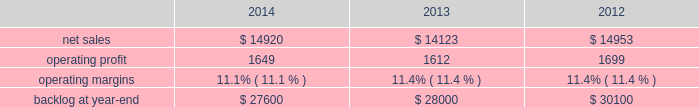2014 , 2013 and 2012 .
The decrease in our consolidated net adjustments for 2014 compared to 2013 was primarily due to a decrease in profit booking rate adjustments at our aeronautics , mfc and mst business segments .
The increase in our consolidated net adjustments for 2013 as compared to 2012 was primarily due to an increase in profit booking rate adjustments at our mst and mfc business segments and , to a lesser extent , the increase in the favorable resolution of contractual matters for the corporation .
The consolidated net adjustments for 2014 are inclusive of approximately $ 650 million in unfavorable items , which include reserves recorded on certain training and logistics solutions programs at mst and net warranty reserve adjustments for various programs ( including jassm and gmlrs ) at mfc as described in the respective business segment 2019s results of operations below .
The consolidated net adjustments for 2013 and 2012 are inclusive of approximately $ 600 million and $ 500 million in unfavorable items , which include a significant profit reduction on the f-35 development contract in both years , as well as a significant profit reduction on the c-5 program in 2013 , each as described in our aeronautics business segment 2019s results of operations discussion below .
Aeronautics our aeronautics business segment is engaged in the research , design , development , manufacture , integration , sustainment , support and upgrade of advanced military aircraft , including combat and air mobility aircraft , unmanned air vehicles and related technologies .
Aeronautics 2019 major programs include the f-35 lightning ii joint strike fighter , c-130 hercules , f-16 fighting falcon , f-22 raptor and the c-5m super galaxy .
Aeronautics 2019 operating results included the following ( in millions ) : .
2014 compared to 2013 aeronautics 2019 net sales for 2014 increased $ 797 million , or 6% ( 6 % ) , compared to 2013 .
The increase was primarily attributable to higher net sales of approximately $ 790 million for f-35 production contracts due to increased volume and sustainment activities ; about $ 55 million for the f-16 program due to increased deliveries ( 17 aircraft delivered in 2014 compared to 13 delivered in 2013 ) partially offset by contract mix ; and approximately $ 45 million for the f-22 program due to increased risk retirements .
The increases were partially offset by lower net sales of approximately $ 55 million for the f-35 development contract due to decreased volume , partially offset by the absence in 2014 of the downward revision to the profit booking rate that occurred in 2013 ; and about $ 40 million for the c-130 program due to fewer deliveries ( 24 aircraft delivered in 2014 compared to 25 delivered in 2013 ) and decreased sustainment activities , partially offset by contract mix .
Aeronautics 2019 operating profit for 2014 increased $ 37 million , or 2% ( 2 % ) , compared to 2013 .
The increase was primarily attributable to higher operating profit of approximately $ 85 million for the f-35 development contract due to the absence in 2014 of the downward revision to the profit booking rate that occurred in 2013 ; about $ 75 million for the f-22 program due to increased risk retirements ; approximately $ 50 million for the c-130 program due to increased risk retirements and contract mix , partially offset by fewer deliveries ; and about $ 25 million for the c-5 program due to the absence in 2014 of the downward revisions to the profit booking rate that occurred in 2013 .
The increases were partially offset by lower operating profit of approximately $ 130 million for the f-16 program due to decreased risk retirements , partially offset by increased deliveries ; and about $ 70 million for sustainment activities due to decreased risk retirements and volume .
Operating profit was comparable for f-35 production contracts as higher volume was offset by lower risk retirements .
Adjustments not related to volume , including net profit booking rate adjustments and other matters , were approximately $ 105 million lower for 2014 compared to 2013 .
2013 compared to 2012 aeronautics 2019 net sales for 2013 decreased $ 830 million , or 6% ( 6 % ) , compared to 2012 .
The decrease was primarily attributable to lower net sales of approximately $ 530 million for the f-16 program due to fewer aircraft deliveries ( 13 aircraft delivered in 2013 compared to 37 delivered in 2012 ) partially offset by aircraft configuration mix ; about $ 385 million for the c-130 program due to fewer aircraft deliveries ( 25 aircraft delivered in 2013 compared to 34 in 2012 ) partially offset by increased sustainment activities ; approximately $ 255 million for the f-22 program , which includes about $ 205 million due to .
What was the percent of the change in the operating profit from 2013 to 2014? 
Computations: ((1649 / 1612) / 1612)
Answer: 0.00063. 